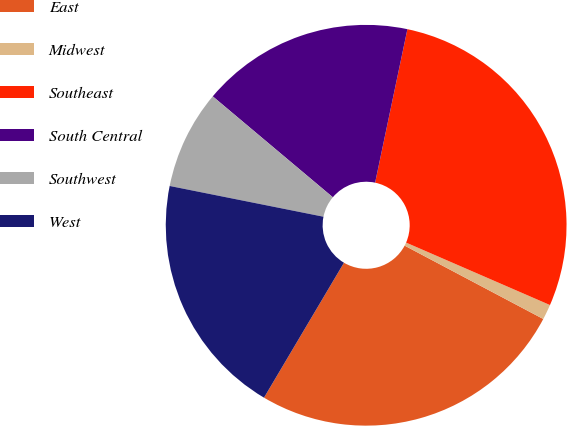Convert chart. <chart><loc_0><loc_0><loc_500><loc_500><pie_chart><fcel>East<fcel>Midwest<fcel>Southeast<fcel>South Central<fcel>Southwest<fcel>West<nl><fcel>25.77%<fcel>1.23%<fcel>28.22%<fcel>17.18%<fcel>7.98%<fcel>19.63%<nl></chart> 